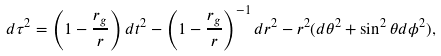<formula> <loc_0><loc_0><loc_500><loc_500>d \tau ^ { 2 } = \left ( 1 - \frac { r _ { g } } { r } \right ) d t ^ { 2 } - \left ( 1 - \frac { r _ { g } } { r } \right ) ^ { - 1 } d r ^ { 2 } - r ^ { 2 } ( d \theta ^ { 2 } + \sin ^ { 2 } \theta d \phi ^ { 2 } ) ,</formula> 